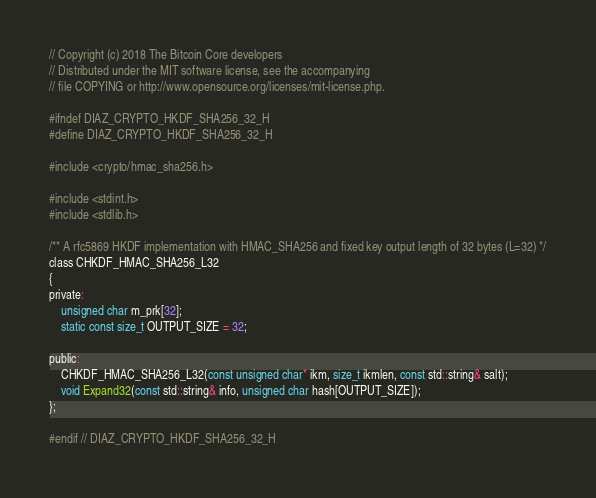<code> <loc_0><loc_0><loc_500><loc_500><_C_>// Copyright (c) 2018 The Bitcoin Core developers
// Distributed under the MIT software license, see the accompanying
// file COPYING or http://www.opensource.org/licenses/mit-license.php.

#ifndef DIAZ_CRYPTO_HKDF_SHA256_32_H
#define DIAZ_CRYPTO_HKDF_SHA256_32_H

#include <crypto/hmac_sha256.h>

#include <stdint.h>
#include <stdlib.h>

/** A rfc5869 HKDF implementation with HMAC_SHA256 and fixed key output length of 32 bytes (L=32) */
class CHKDF_HMAC_SHA256_L32
{
private:
    unsigned char m_prk[32];
    static const size_t OUTPUT_SIZE = 32;

public:
    CHKDF_HMAC_SHA256_L32(const unsigned char* ikm, size_t ikmlen, const std::string& salt);
    void Expand32(const std::string& info, unsigned char hash[OUTPUT_SIZE]);
};

#endif // DIAZ_CRYPTO_HKDF_SHA256_32_H
</code> 